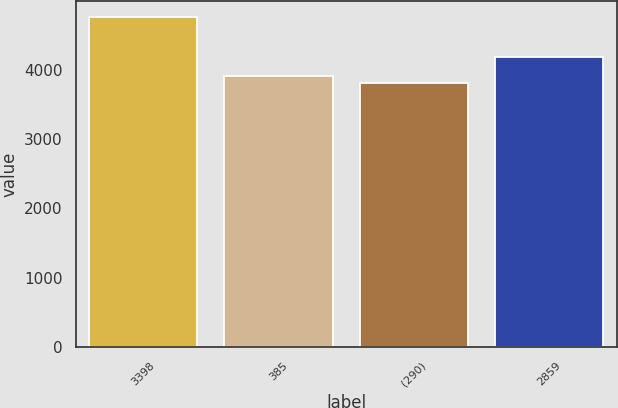Convert chart to OTSL. <chart><loc_0><loc_0><loc_500><loc_500><bar_chart><fcel>3398<fcel>385<fcel>(290)<fcel>2859<nl><fcel>4753<fcel>3901.6<fcel>3807<fcel>4180<nl></chart> 